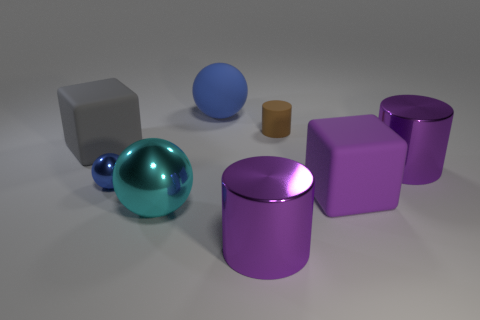Subtract all cylinders. How many objects are left? 5 Add 1 tiny matte things. How many objects exist? 9 Subtract all blue metallic things. Subtract all blue objects. How many objects are left? 5 Add 4 cylinders. How many cylinders are left? 7 Add 3 big cyan cylinders. How many big cyan cylinders exist? 3 Subtract 1 gray blocks. How many objects are left? 7 